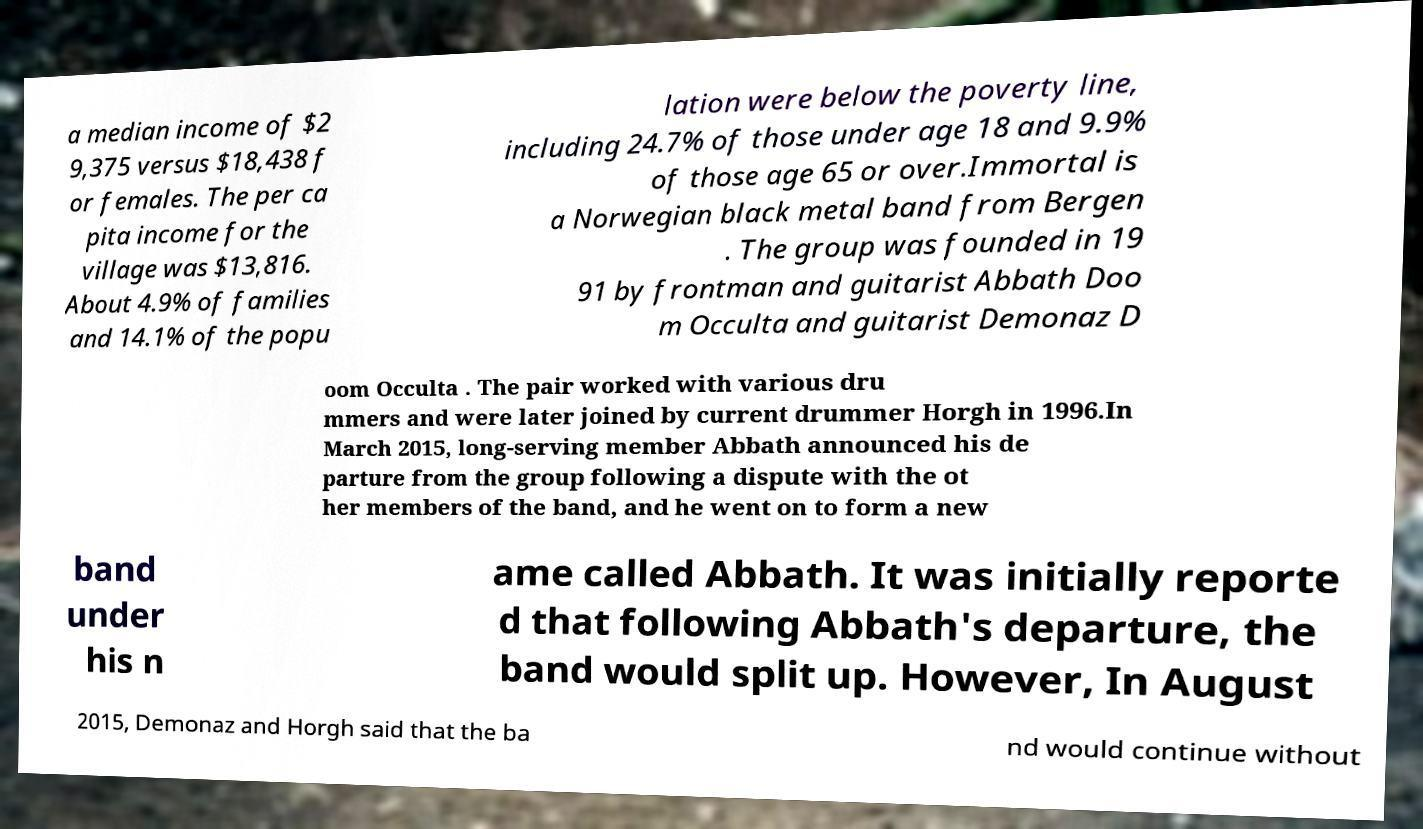There's text embedded in this image that I need extracted. Can you transcribe it verbatim? a median income of $2 9,375 versus $18,438 f or females. The per ca pita income for the village was $13,816. About 4.9% of families and 14.1% of the popu lation were below the poverty line, including 24.7% of those under age 18 and 9.9% of those age 65 or over.Immortal is a Norwegian black metal band from Bergen . The group was founded in 19 91 by frontman and guitarist Abbath Doo m Occulta and guitarist Demonaz D oom Occulta . The pair worked with various dru mmers and were later joined by current drummer Horgh in 1996.In March 2015, long-serving member Abbath announced his de parture from the group following a dispute with the ot her members of the band, and he went on to form a new band under his n ame called Abbath. It was initially reporte d that following Abbath's departure, the band would split up. However, In August 2015, Demonaz and Horgh said that the ba nd would continue without 